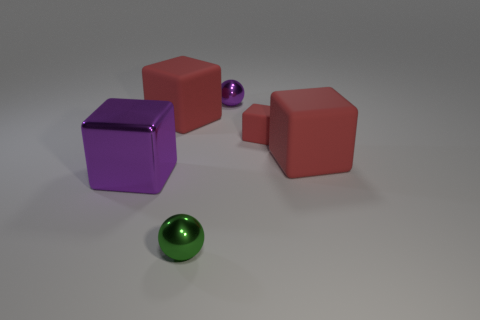How many red blocks must be subtracted to get 1 red blocks? 2 Subtract all brown cylinders. How many red blocks are left? 3 Add 3 rubber objects. How many objects exist? 9 Subtract all blocks. How many objects are left? 2 Subtract 0 yellow cubes. How many objects are left? 6 Subtract all red spheres. Subtract all small matte things. How many objects are left? 5 Add 1 large cubes. How many large cubes are left? 4 Add 5 big yellow metal cubes. How many big yellow metal cubes exist? 5 